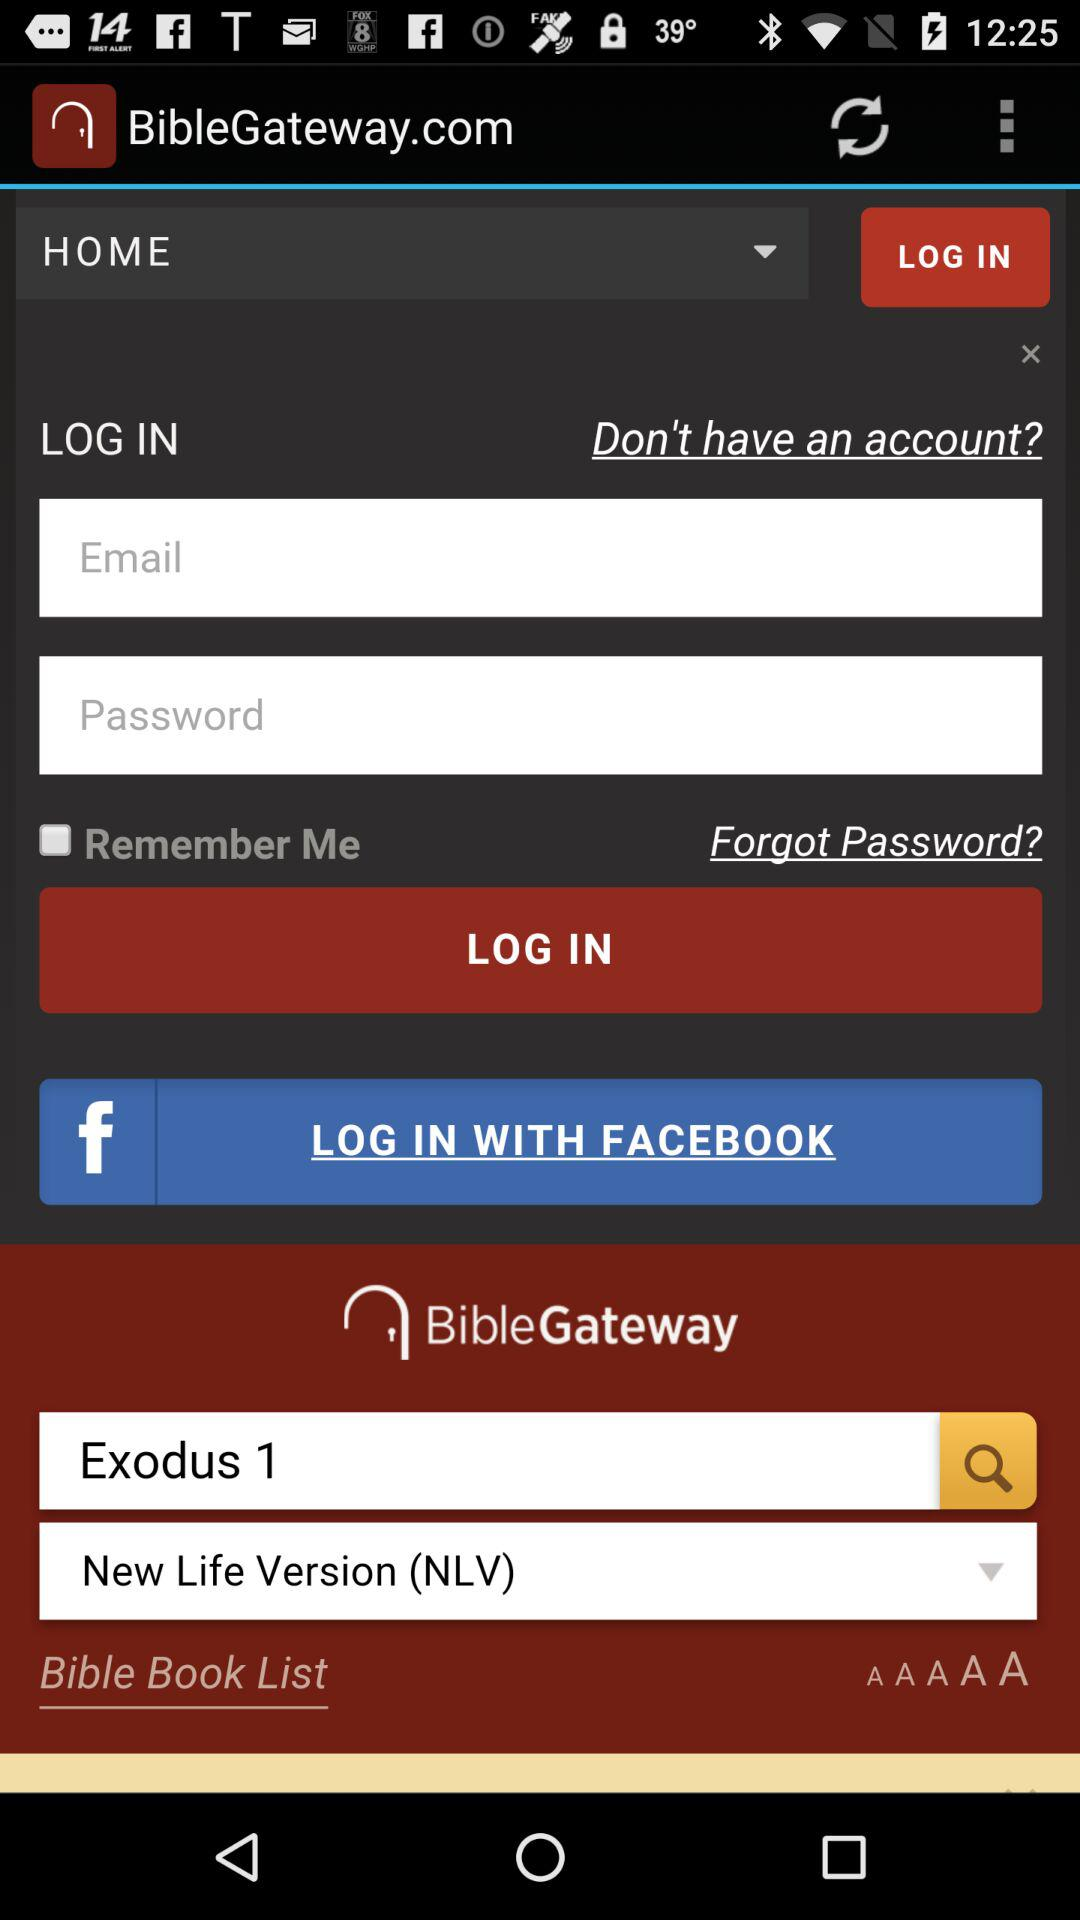What are the different options available to log in? The different options available to log in are "Email" and "FACEBOOK". 